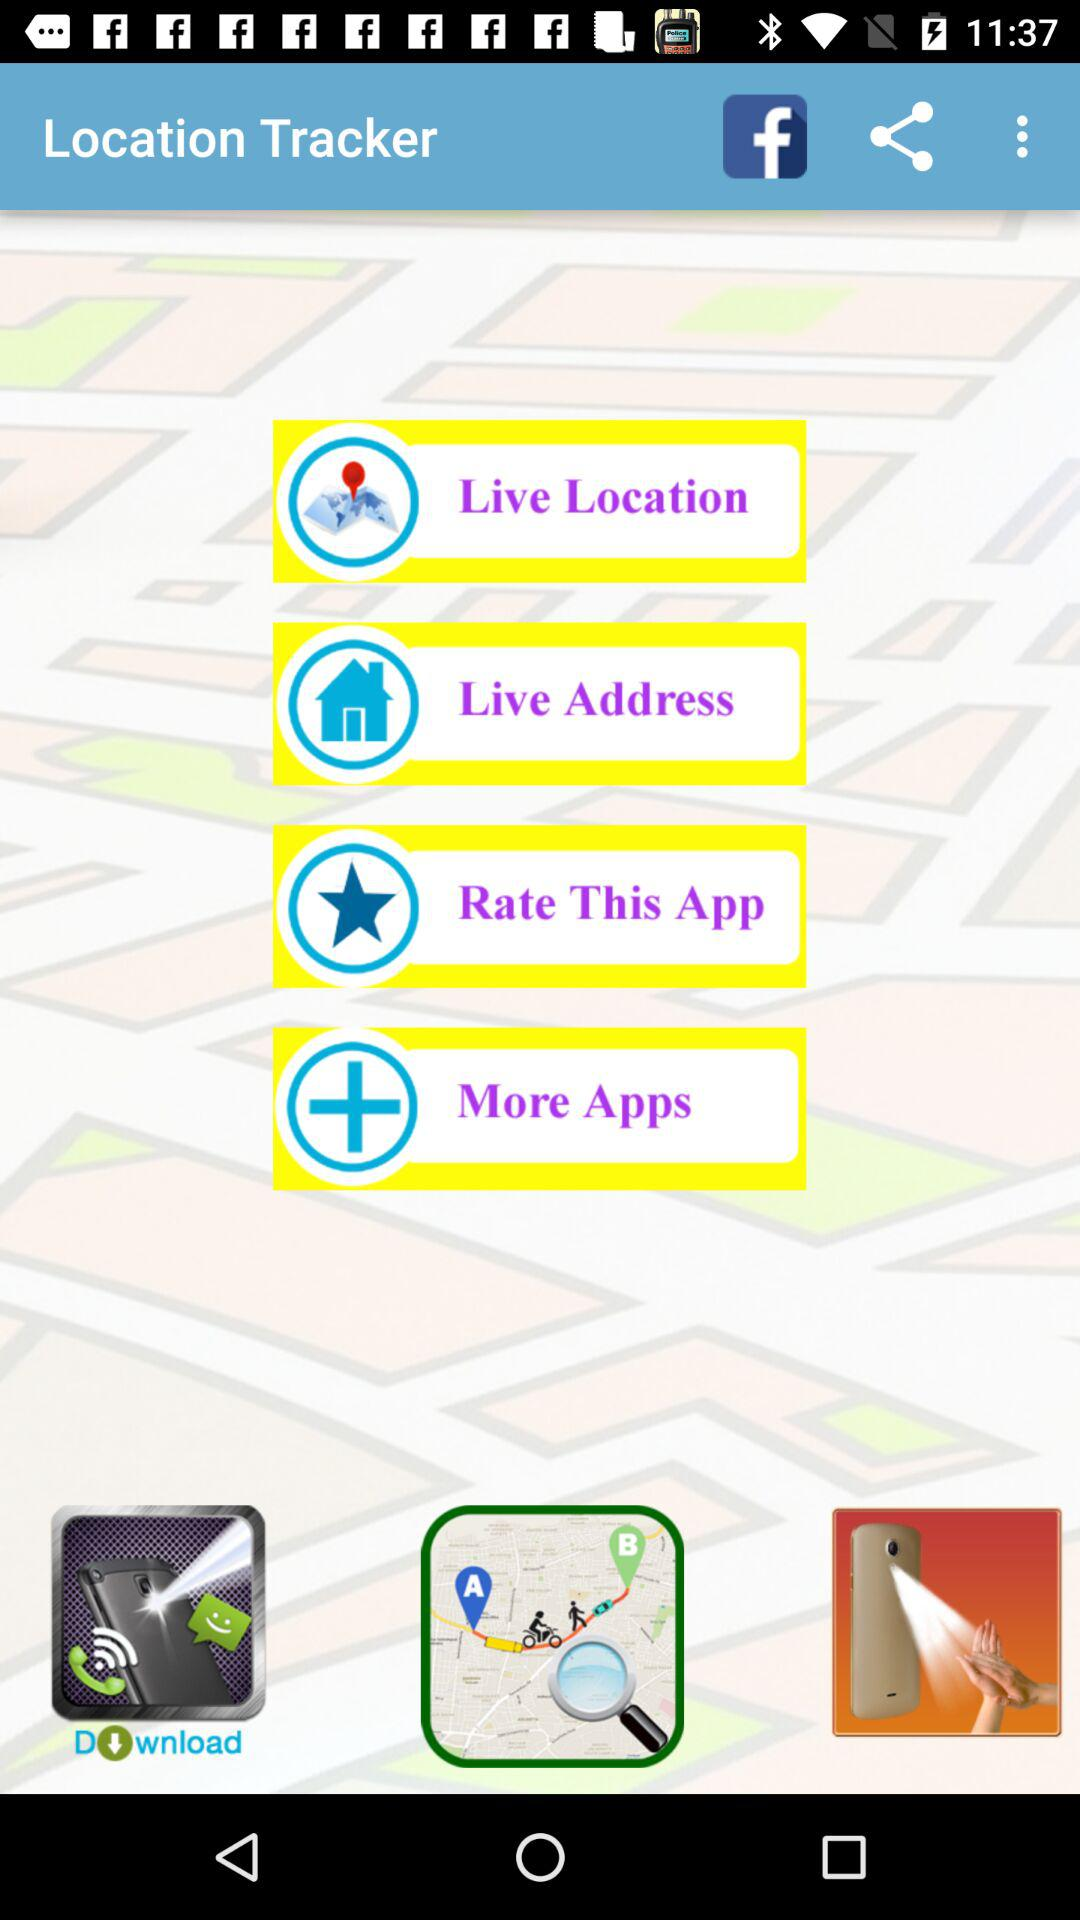What is the application name? The application name is "Location Tracker". 